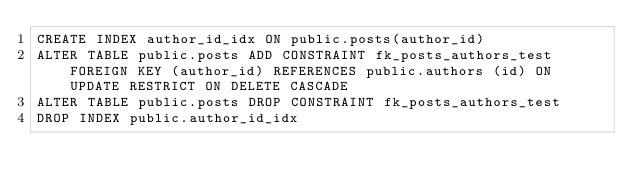Convert code to text. <code><loc_0><loc_0><loc_500><loc_500><_SQL_>CREATE INDEX author_id_idx ON public.posts(author_id)
ALTER TABLE public.posts ADD CONSTRAINT fk_posts_authors_test FOREIGN KEY (author_id) REFERENCES public.authors (id) ON UPDATE RESTRICT ON DELETE CASCADE
ALTER TABLE public.posts DROP CONSTRAINT fk_posts_authors_test
DROP INDEX public.author_id_idx
</code> 